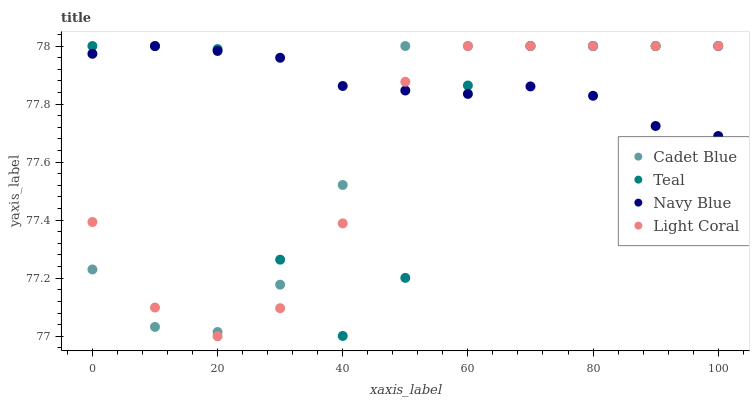Does Light Coral have the minimum area under the curve?
Answer yes or no. Yes. Does Navy Blue have the maximum area under the curve?
Answer yes or no. Yes. Does Cadet Blue have the minimum area under the curve?
Answer yes or no. No. Does Cadet Blue have the maximum area under the curve?
Answer yes or no. No. Is Navy Blue the smoothest?
Answer yes or no. Yes. Is Teal the roughest?
Answer yes or no. Yes. Is Cadet Blue the smoothest?
Answer yes or no. No. Is Cadet Blue the roughest?
Answer yes or no. No. Does Light Coral have the lowest value?
Answer yes or no. Yes. Does Cadet Blue have the lowest value?
Answer yes or no. No. Does Teal have the highest value?
Answer yes or no. Yes. Does Navy Blue have the highest value?
Answer yes or no. No. Does Navy Blue intersect Cadet Blue?
Answer yes or no. Yes. Is Navy Blue less than Cadet Blue?
Answer yes or no. No. Is Navy Blue greater than Cadet Blue?
Answer yes or no. No. 